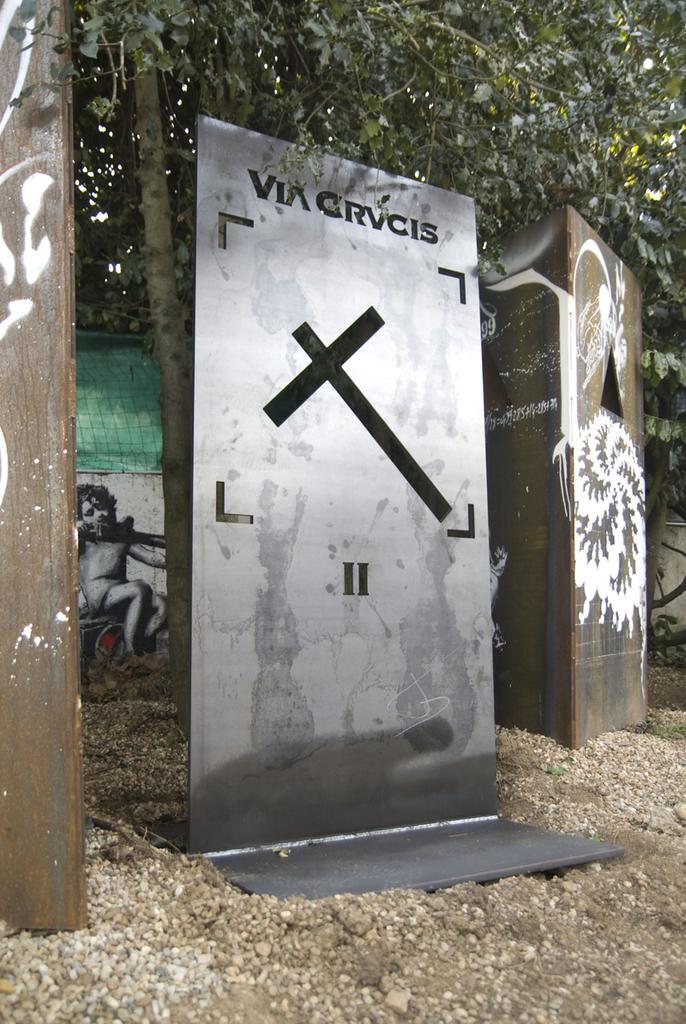Can you describe this image briefly? In this image there is a metal board in the middle and there are wooden boards on either side of it. In the background there is a tree. At the bottom there is sand on which there are stones. 